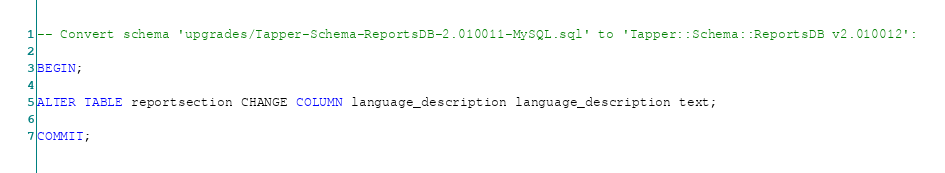<code> <loc_0><loc_0><loc_500><loc_500><_SQL_>-- Convert schema 'upgrades/Tapper-Schema-ReportsDB-2.010011-MySQL.sql' to 'Tapper::Schema::ReportsDB v2.010012':

BEGIN;

ALTER TABLE reportsection CHANGE COLUMN language_description language_description text;

COMMIT;
</code> 